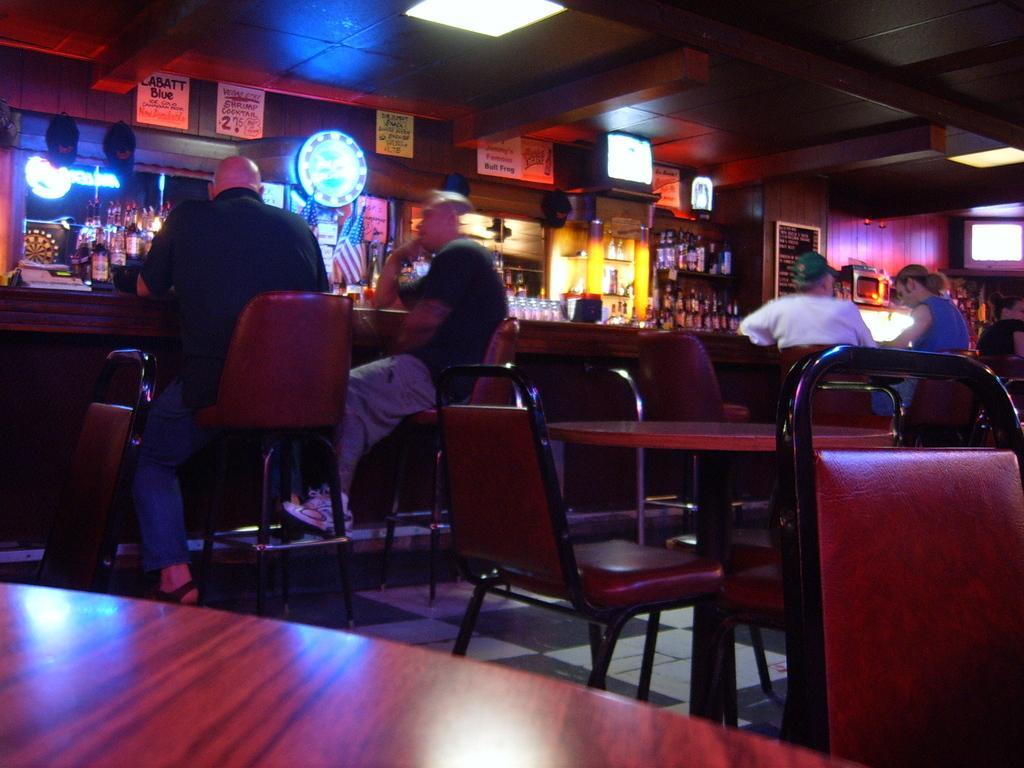Could you give a brief overview of what you see in this image? This image consist of four persons. They are sitting in the chairs. There are many tables and chairs. In the background, there are wine bottles and some posters stick on the wall. At the top, there is a roof along with lights. To the left, the man sitting in a chair is wearing black shirt. 